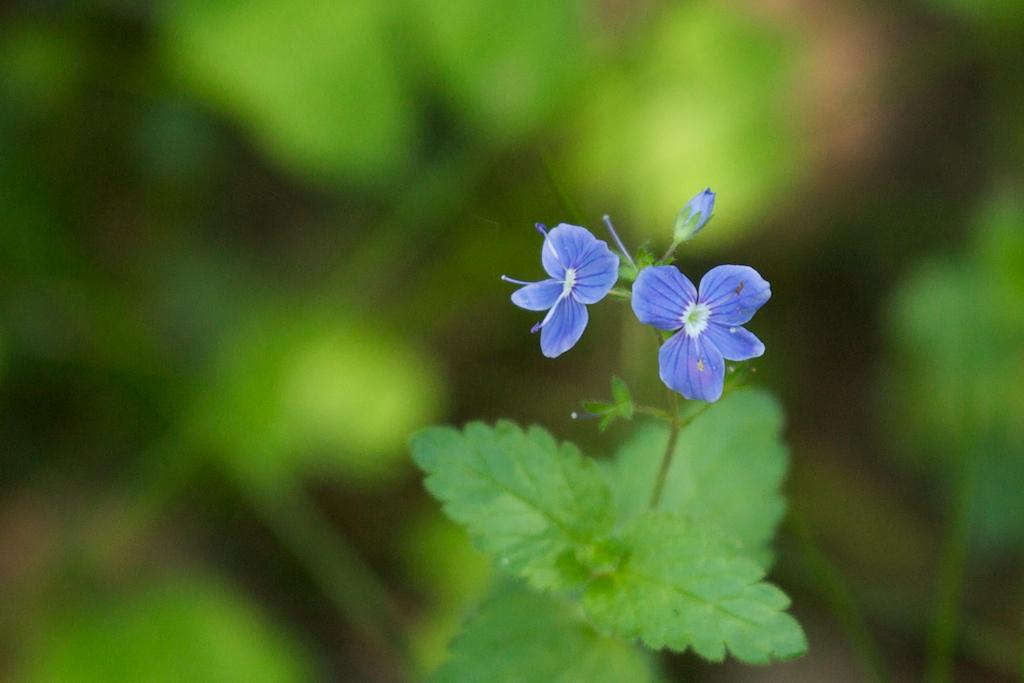What type of flora can be seen in the image? There are flowers and plants in the image. What colors are the flowers in the image? The flowers are in white and purple colors. What color are the plants in the image? The plants are in green color. Is there a chance of rain in the image? The image does not provide any information about the weather or the possibility of rain. 